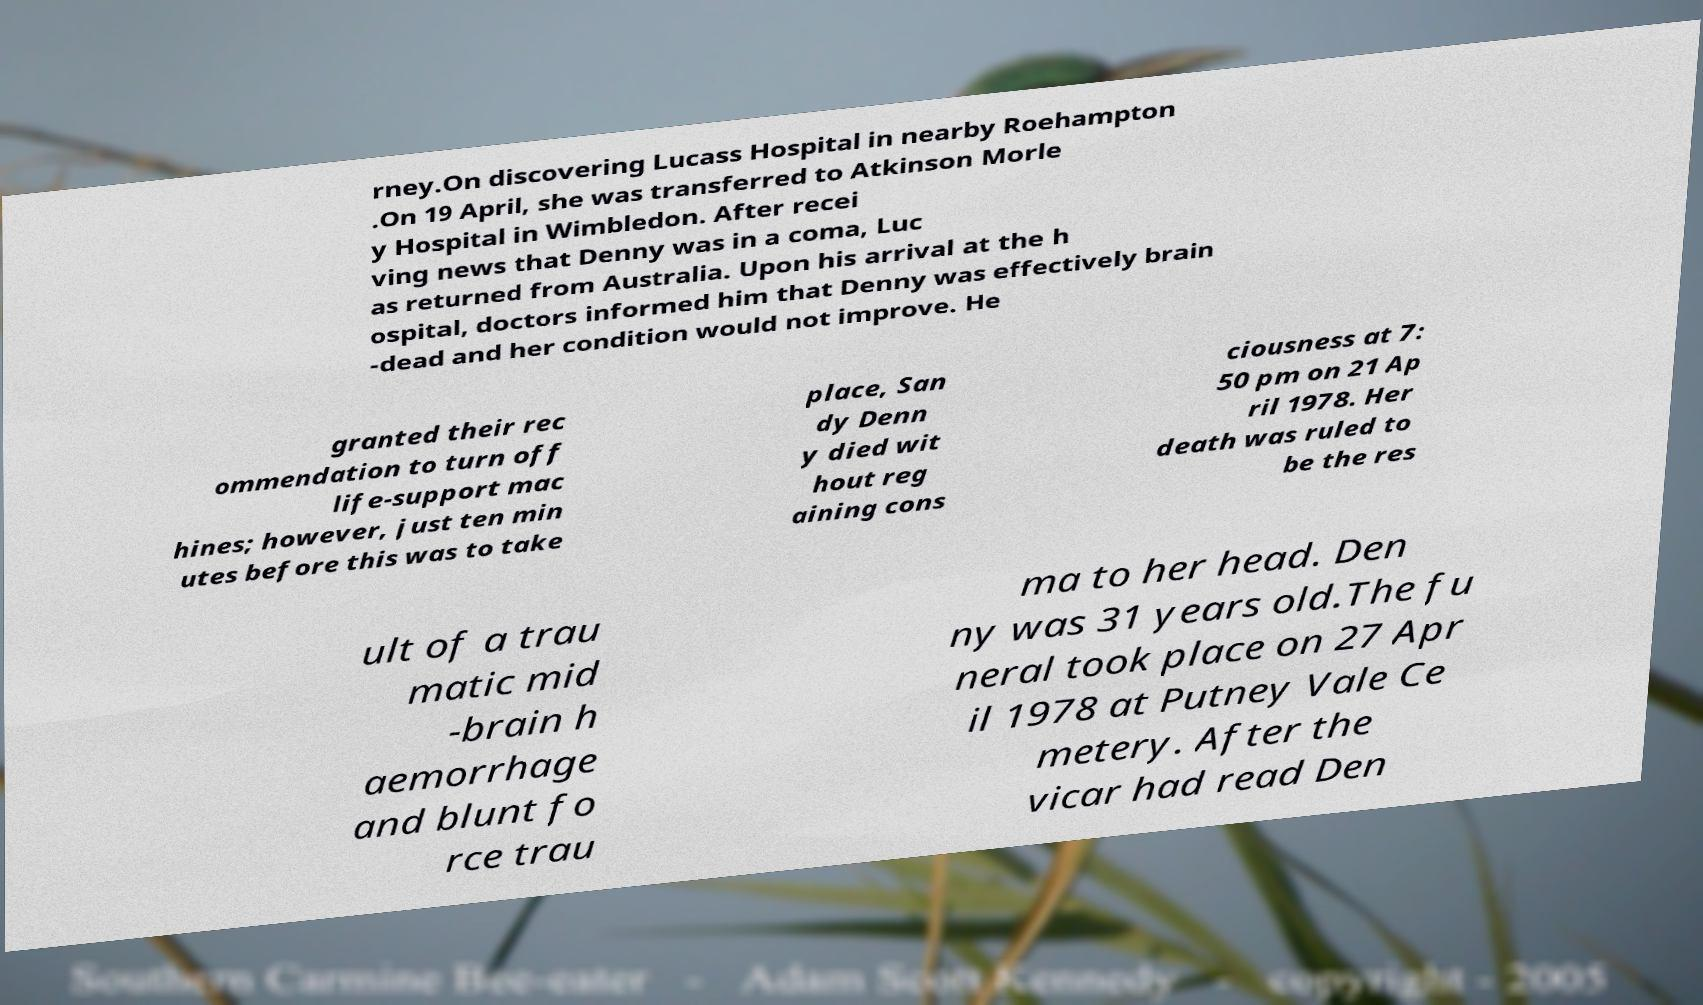For documentation purposes, I need the text within this image transcribed. Could you provide that? rney.On discovering Lucass Hospital in nearby Roehampton .On 19 April, she was transferred to Atkinson Morle y Hospital in Wimbledon. After recei ving news that Denny was in a coma, Luc as returned from Australia. Upon his arrival at the h ospital, doctors informed him that Denny was effectively brain -dead and her condition would not improve. He granted their rec ommendation to turn off life-support mac hines; however, just ten min utes before this was to take place, San dy Denn y died wit hout reg aining cons ciousness at 7: 50 pm on 21 Ap ril 1978. Her death was ruled to be the res ult of a trau matic mid -brain h aemorrhage and blunt fo rce trau ma to her head. Den ny was 31 years old.The fu neral took place on 27 Apr il 1978 at Putney Vale Ce metery. After the vicar had read Den 